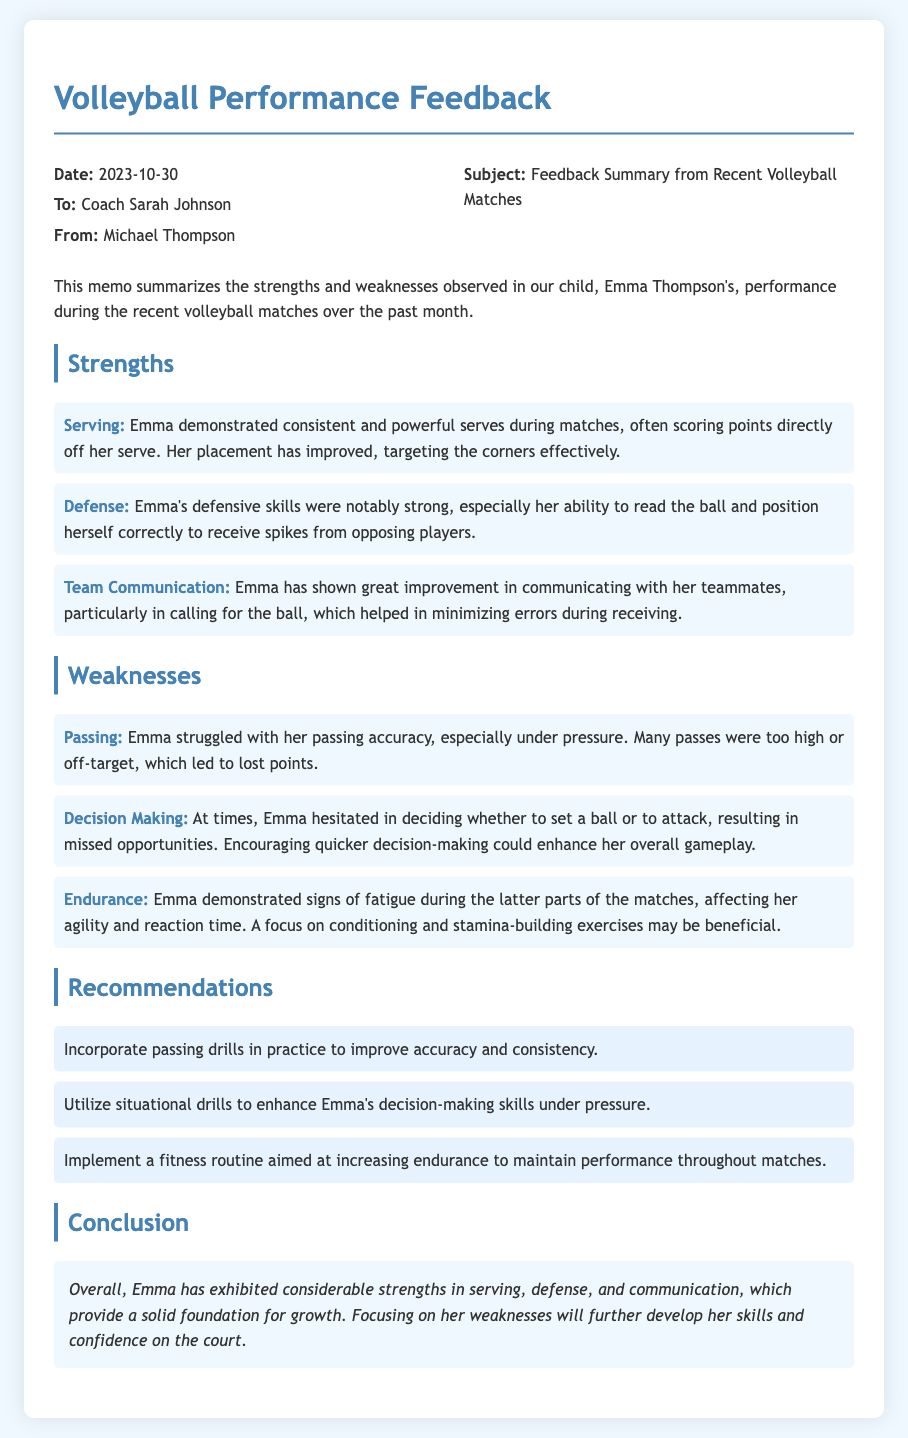what date was the memo created? The date of the memo is mentioned at the beginning, which is when it was written.
Answer: 2023-10-30 who is the recipient of the memo? The memo specifies the recipient's name in the "To" section.
Answer: Coach Sarah Johnson what are the three strengths highlighted in the memo? The memo lists Emma's strengths under the "Strengths" section, focusing on her skills.
Answer: Serving, Defense, Team Communication what specific weakness relates to Emma's passing? The memo describes a particular aspect of Emma's gameplay that needs improvement.
Answer: Passing accuracy how many recommendations are provided in the document? The number of recommendations can be counted in the "Recommendations" section of the memo.
Answer: Three what is the main focus of the conclusion? The conclusion summarizes the overall evaluation of Emma's performance, focusing on strengths and weaknesses.
Answer: Growth and development why is endurance mentioned as a weakness? The memo discusses Emma's fatigue impacting her performance, explaining its relevance to her gameplay.
Answer: Signs of fatigue what kind of drills are suggested to improve decision-making? The memo mentions specific types of practice drills to enhance a particular skill related to gameplay.
Answer: Situational drills 